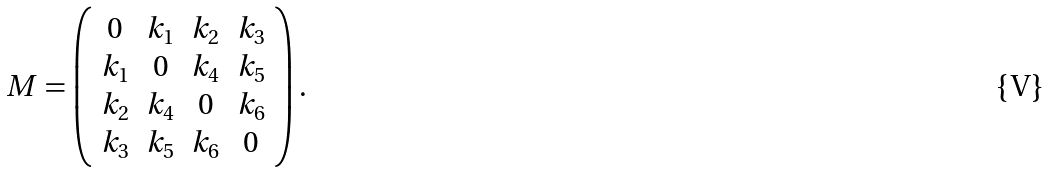<formula> <loc_0><loc_0><loc_500><loc_500>M = \left ( \begin{array} { c c c c } 0 & k _ { 1 } & k _ { 2 } & k _ { 3 } \\ k _ { 1 } & 0 & k _ { 4 } & k _ { 5 } \\ k _ { 2 } & k _ { 4 } & 0 & k _ { 6 } \\ k _ { 3 } & k _ { 5 } & k _ { 6 } & 0 \end{array} \right ) .</formula> 